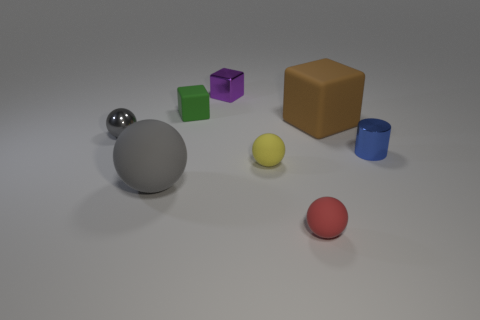Is the number of red rubber things greater than the number of large blue objects? Upon examining the image, there appears to be one red rubber ball and one large blue cylinder. Therefore, the number of red rubber things is equal to the number of large blue objects. 